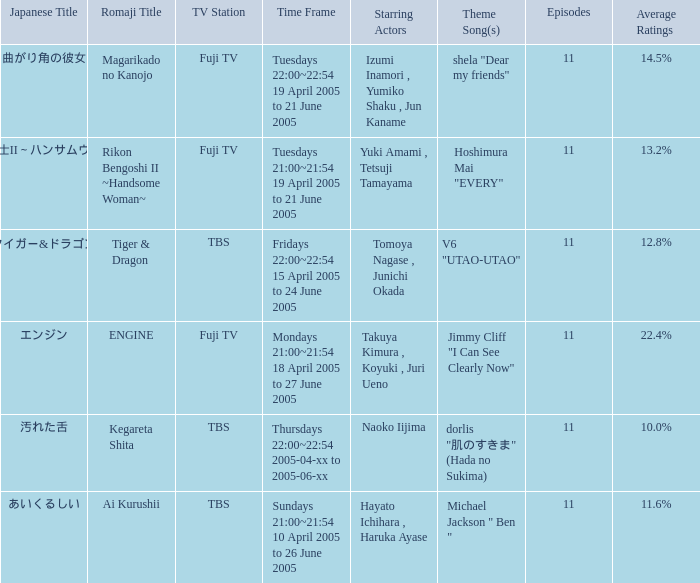Can you give me this table as a dict? {'header': ['Japanese Title', 'Romaji Title', 'TV Station', 'Time Frame', 'Starring Actors', 'Theme Song(s)', 'Episodes', 'Average Ratings'], 'rows': [['曲がり角の彼女', 'Magarikado no Kanojo', 'Fuji TV', 'Tuesdays 22:00~22:54 19 April 2005 to 21 June 2005', 'Izumi Inamori , Yumiko Shaku , Jun Kaname', 'shela "Dear my friends"', '11', '14.5%'], ['離婚弁護士II～ハンサムウーマン～', 'Rikon Bengoshi II ~Handsome Woman~', 'Fuji TV', 'Tuesdays 21:00~21:54 19 April 2005 to 21 June 2005', 'Yuki Amami , Tetsuji Tamayama', 'Hoshimura Mai "EVERY"', '11', '13.2%'], ['タイガー&ドラゴン', 'Tiger & Dragon', 'TBS', 'Fridays 22:00~22:54 15 April 2005 to 24 June 2005', 'Tomoya Nagase , Junichi Okada', 'V6 "UTAO-UTAO"', '11', '12.8%'], ['エンジン', 'ENGINE', 'Fuji TV', 'Mondays 21:00~21:54 18 April 2005 to 27 June 2005', 'Takuya Kimura , Koyuki , Juri Ueno', 'Jimmy Cliff "I Can See Clearly Now"', '11', '22.4%'], ['汚れた舌', 'Kegareta Shita', 'TBS', 'Thursdays 22:00~22:54 2005-04-xx to 2005-06-xx', 'Naoko Iijima', 'dorlis "肌のすきま" (Hada no Sukima)', '11', '10.0%'], ['あいくるしい', 'Ai Kurushii', 'TBS', 'Sundays 21:00~21:54 10 April 2005 to 26 June 2005', 'Hayato Ichihara , Haruka Ayase', 'Michael Jackson " Ben "', '11', '11.6%']]} What is the theme song for Magarikado no Kanojo? Shela "dear my friends". 